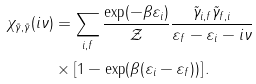Convert formula to latex. <formula><loc_0><loc_0><loc_500><loc_500>\chi _ { \tilde { \gamma } , \tilde { \gamma } } ( i \nu ) & = \sum _ { i , f } \frac { \exp ( - \beta \varepsilon _ { i } ) } { \mathcal { Z } } \frac { \tilde { \gamma } _ { i , f } \tilde { \gamma } _ { f , i } } { \varepsilon _ { f } - \varepsilon _ { i } - i \nu } \\ & \times \left [ 1 - \exp ( \beta ( \varepsilon _ { i } - \varepsilon _ { f } ) ) \right ] .</formula> 